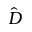<formula> <loc_0><loc_0><loc_500><loc_500>\hat { D }</formula> 